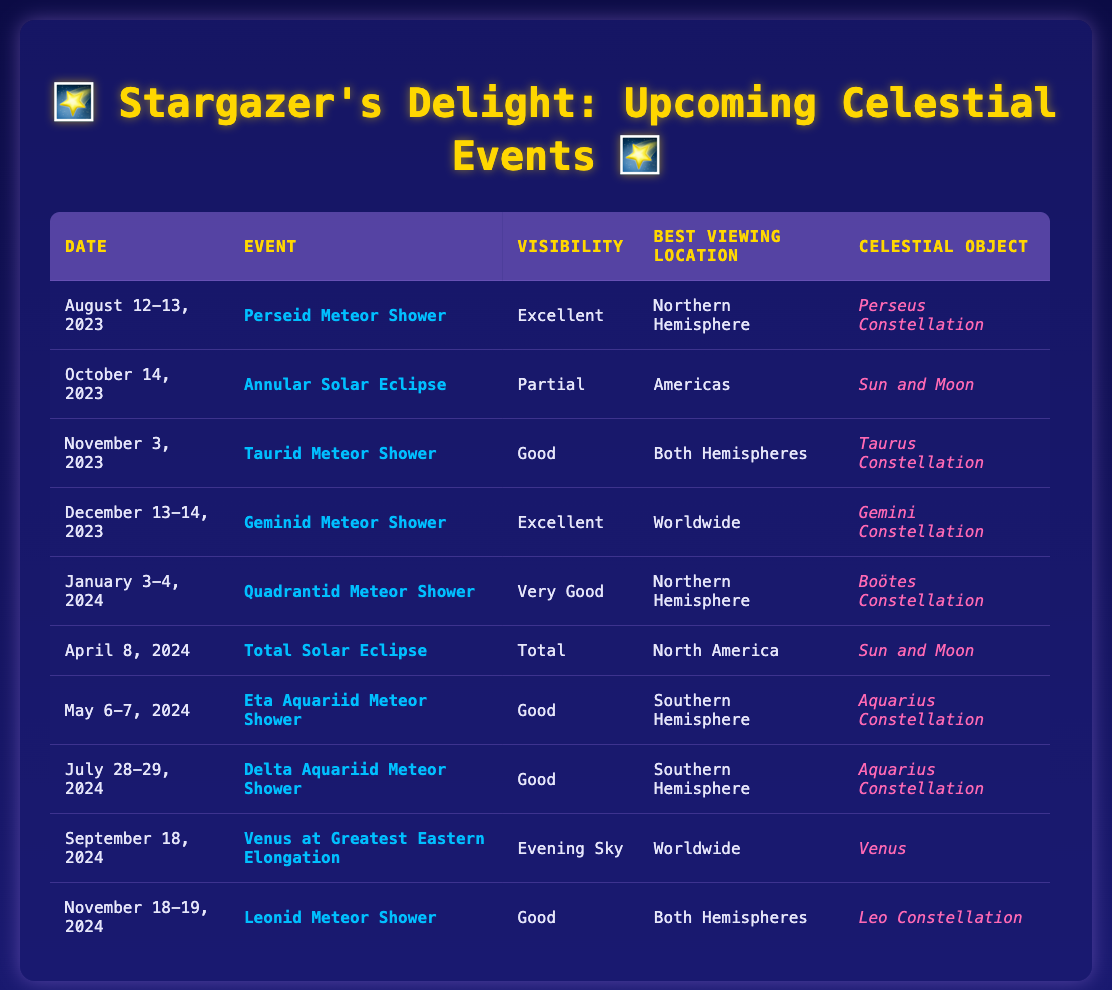What astronomical event occurs on October 14, 2023? From the table, on October 14, 2023, the event listed is the "Annular Solar Eclipse."
Answer: Annular Solar Eclipse Is the visibility of the Geminid Meteor Shower excellent? Yes, according to the table, the Geminid Meteor Shower on December 13-14, 2023, has "Excellent" visibility.
Answer: Yes How many meteor showers are scheduled for November? The table shows that there are two meteor showers scheduled for November: the Taurid Meteor Shower on November 3, 2023, and the Leonid Meteor Shower on November 18-19, 2024, totaling two showers.
Answer: 2 Which event has the best visibility: Quadrantid Meteor Shower or Eta Aquariid Meteor Shower? The visibility of the Quadrantid Meteor Shower on January 3-4, 2024, is "Very Good," while the Eta Aquariid Meteor Shower on May 6-7, 2024, has "Good" visibility. Comparing these, "Very Good" is better than "Good."
Answer: Quadrantid Meteor Shower During which event is the Sun and Moon the celestial objects involved? The table shows that both the "Annular Solar Eclipse" on October 14, 2023, and the "Total Solar Eclipse" on April 8, 2024, involve the Sun and Moon as the celestial objects.
Answer: Annular Solar Eclipse and Total Solar Eclipse What is the total number of meteor showers listed in the table? Counting the rows that mention meteor showers in the table, we find there are six events: Perseid, Taurid, Geminid, Quadrantid, Eta Aquariid, and Delta Aquariid Meteor Showers. Adding these confirms the total is six.
Answer: 6 Can meteor showers be seen from both hemispheres in November? Yes, the Taurid Meteor Shower (November 3, 2023) and Leonid Meteor Shower (November 18-19, 2024) are both indicated as visible from "Both Hemispheres."
Answer: Yes Which event occurs closest to the end of the year? The table lists the Geminid Meteor Shower on December 13-14, 2023, as the last event scheduled before the end of the year 2023.
Answer: Geminid Meteor Shower 